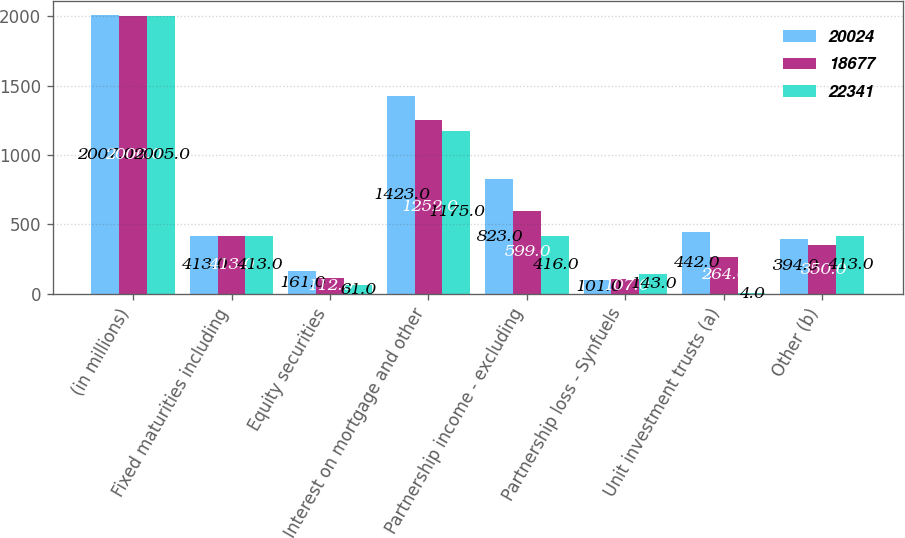Convert chart. <chart><loc_0><loc_0><loc_500><loc_500><stacked_bar_chart><ecel><fcel>(in millions)<fcel>Fixed maturities including<fcel>Equity securities<fcel>Interest on mortgage and other<fcel>Partnership income - excluding<fcel>Partnership loss - Synfuels<fcel>Unit investment trusts (a)<fcel>Other (b)<nl><fcel>20024<fcel>2007<fcel>413<fcel>161<fcel>1423<fcel>823<fcel>101<fcel>442<fcel>394<nl><fcel>18677<fcel>2006<fcel>413<fcel>112<fcel>1252<fcel>599<fcel>107<fcel>264<fcel>350<nl><fcel>22341<fcel>2005<fcel>413<fcel>61<fcel>1175<fcel>416<fcel>143<fcel>4<fcel>413<nl></chart> 